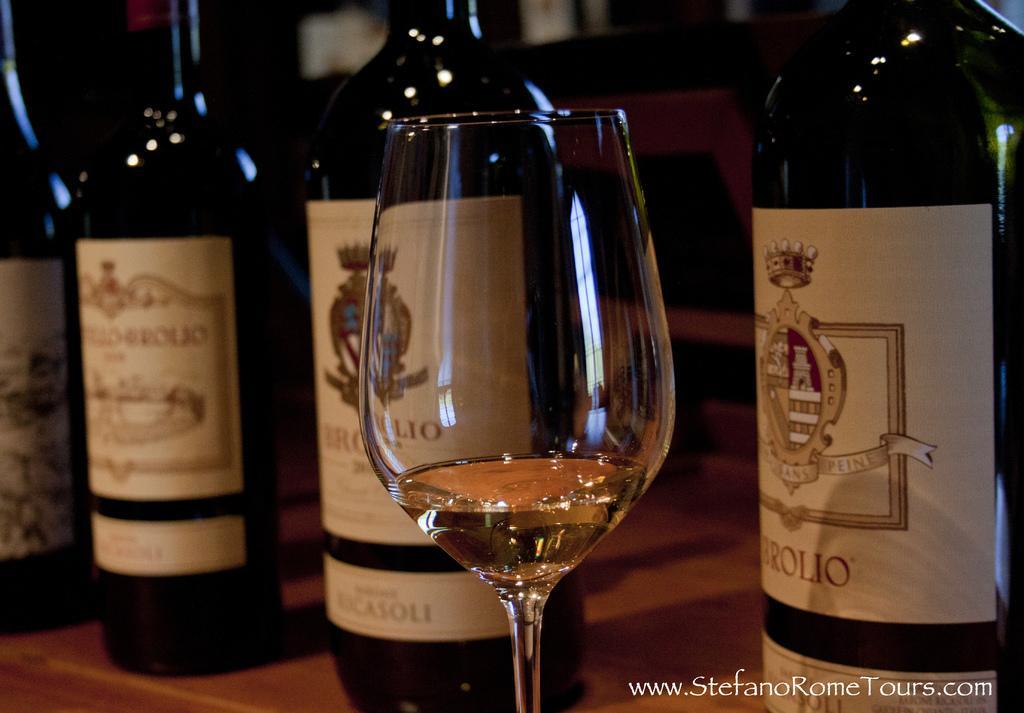Describe this image in one or two sentences. This is a zoomed in picture. In the center we can see a glass of a drink and some bottles are placed on the top of the table. In the background there is a chair and some other objects. At the bottom right corner there is a text on the image. 